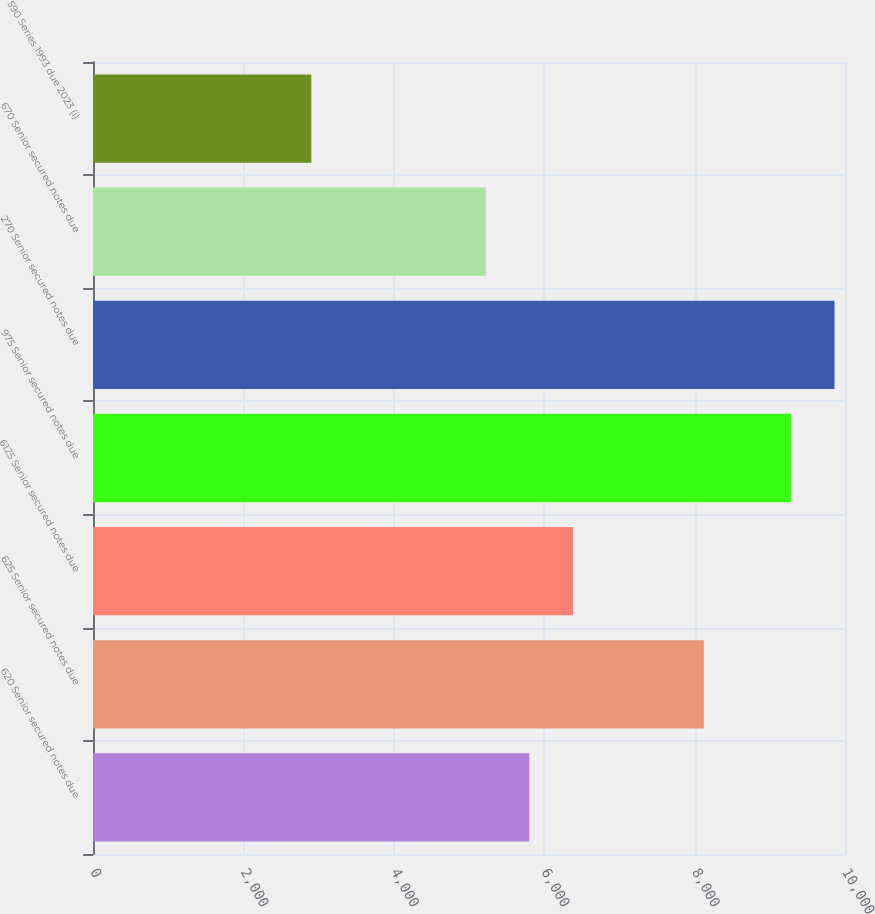Convert chart to OTSL. <chart><loc_0><loc_0><loc_500><loc_500><bar_chart><fcel>620 Senior secured notes due<fcel>625 Senior secured notes due<fcel>6125 Senior secured notes due<fcel>975 Senior secured notes due<fcel>270 Senior secured notes due<fcel>670 Senior secured notes due<fcel>590 Series 1993 due 2023 (i)<nl><fcel>5802<fcel>8121.2<fcel>6381.8<fcel>9280.8<fcel>9860.6<fcel>5222.2<fcel>2903<nl></chart> 